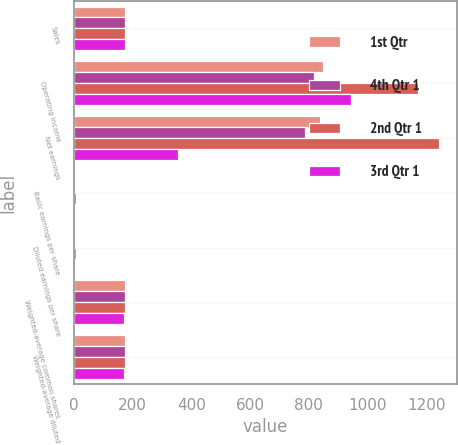<chart> <loc_0><loc_0><loc_500><loc_500><stacked_bar_chart><ecel><fcel>Sales<fcel>Operating income<fcel>Net earnings<fcel>Basic earnings per share<fcel>Diluted earnings per share<fcel>Weighted-average common shares<fcel>Weighted-average diluted<nl><fcel>1st Qtr<fcel>174.4<fcel>848<fcel>840<fcel>4.82<fcel>4.79<fcel>174.3<fcel>175.4<nl><fcel>4th Qtr 1<fcel>174.4<fcel>817<fcel>789<fcel>4.52<fcel>4.5<fcel>174.5<fcel>175.4<nl><fcel>2nd Qtr 1<fcel>174.4<fcel>1172<fcel>1244<fcel>7.15<fcel>7.11<fcel>174.1<fcel>174.9<nl><fcel>3rd Qtr 1<fcel>174.4<fcel>943<fcel>356<fcel>2.07<fcel>2.06<fcel>171.8<fcel>172.6<nl></chart> 